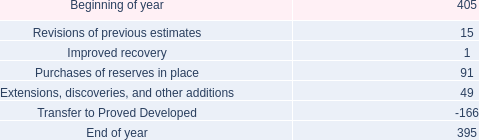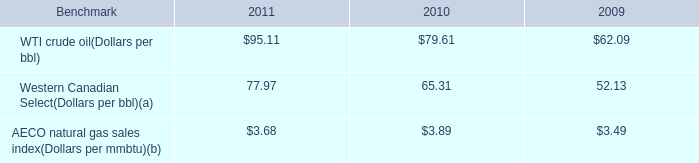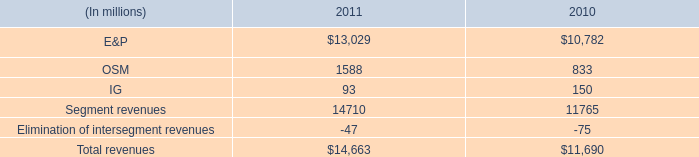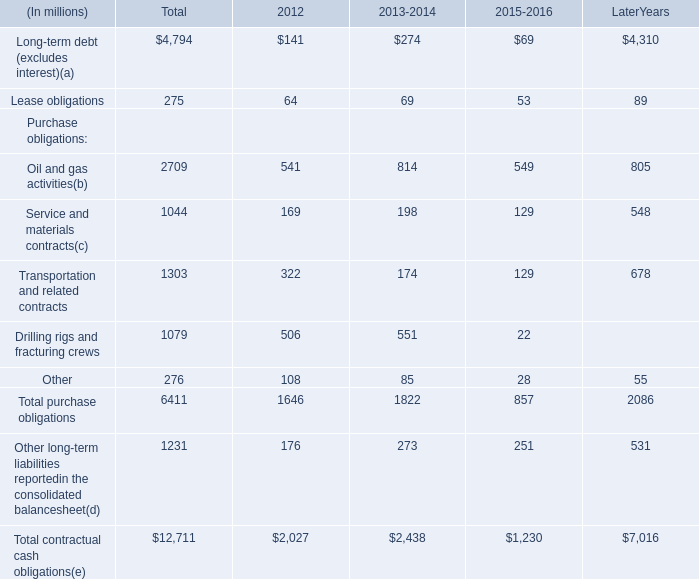What is the value of the Total purchase obligations in 2012? (in million) 
Answer: 1646. 